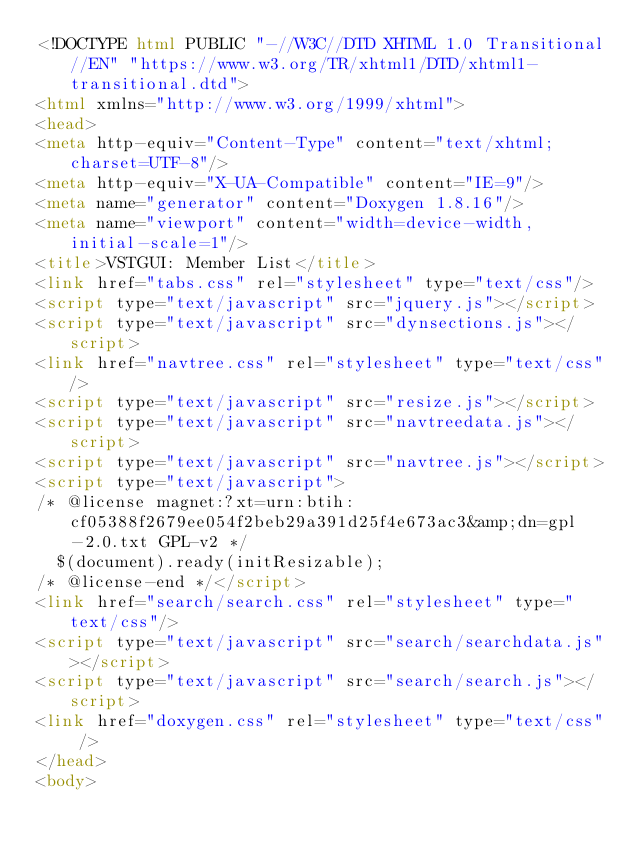Convert code to text. <code><loc_0><loc_0><loc_500><loc_500><_HTML_><!DOCTYPE html PUBLIC "-//W3C//DTD XHTML 1.0 Transitional//EN" "https://www.w3.org/TR/xhtml1/DTD/xhtml1-transitional.dtd">
<html xmlns="http://www.w3.org/1999/xhtml">
<head>
<meta http-equiv="Content-Type" content="text/xhtml;charset=UTF-8"/>
<meta http-equiv="X-UA-Compatible" content="IE=9"/>
<meta name="generator" content="Doxygen 1.8.16"/>
<meta name="viewport" content="width=device-width, initial-scale=1"/>
<title>VSTGUI: Member List</title>
<link href="tabs.css" rel="stylesheet" type="text/css"/>
<script type="text/javascript" src="jquery.js"></script>
<script type="text/javascript" src="dynsections.js"></script>
<link href="navtree.css" rel="stylesheet" type="text/css"/>
<script type="text/javascript" src="resize.js"></script>
<script type="text/javascript" src="navtreedata.js"></script>
<script type="text/javascript" src="navtree.js"></script>
<script type="text/javascript">
/* @license magnet:?xt=urn:btih:cf05388f2679ee054f2beb29a391d25f4e673ac3&amp;dn=gpl-2.0.txt GPL-v2 */
  $(document).ready(initResizable);
/* @license-end */</script>
<link href="search/search.css" rel="stylesheet" type="text/css"/>
<script type="text/javascript" src="search/searchdata.js"></script>
<script type="text/javascript" src="search/search.js"></script>
<link href="doxygen.css" rel="stylesheet" type="text/css" />
</head>
<body></code> 